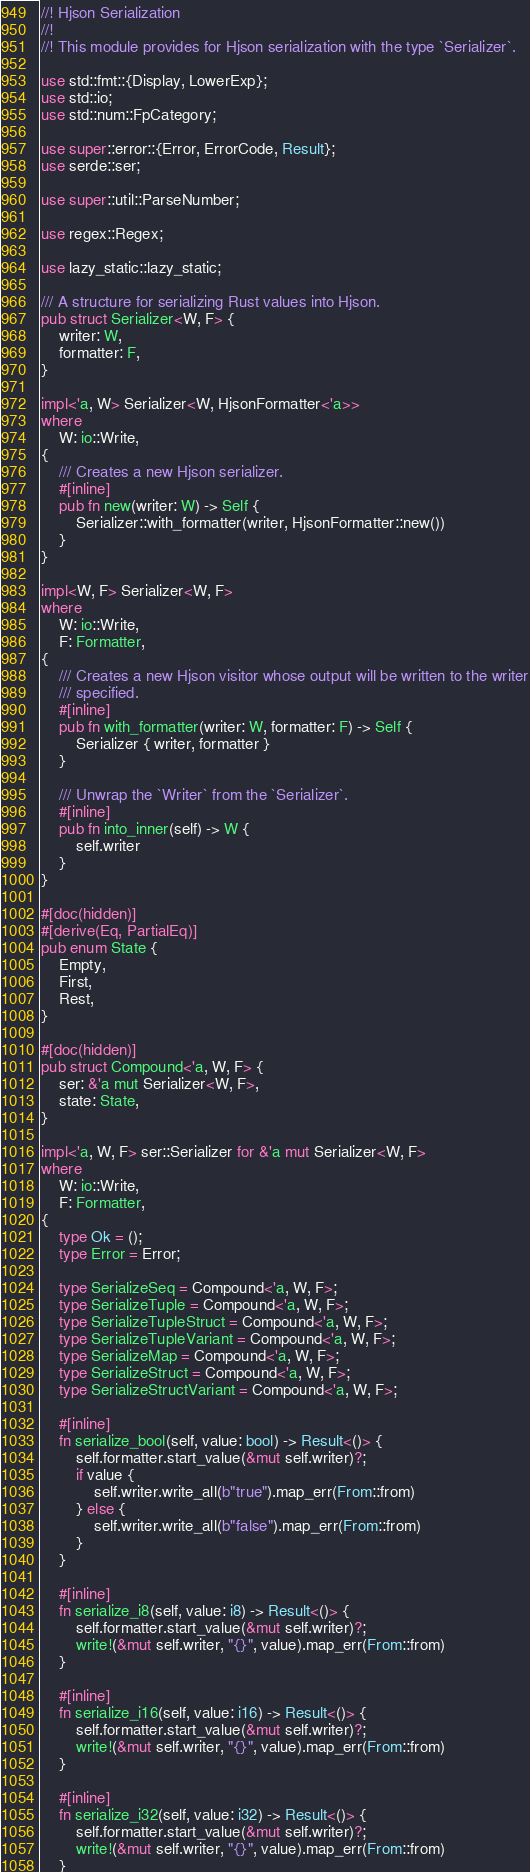<code> <loc_0><loc_0><loc_500><loc_500><_Rust_>//! Hjson Serialization
//!
//! This module provides for Hjson serialization with the type `Serializer`.

use std::fmt::{Display, LowerExp};
use std::io;
use std::num::FpCategory;

use super::error::{Error, ErrorCode, Result};
use serde::ser;

use super::util::ParseNumber;

use regex::Regex;

use lazy_static::lazy_static;

/// A structure for serializing Rust values into Hjson.
pub struct Serializer<W, F> {
    writer: W,
    formatter: F,
}

impl<'a, W> Serializer<W, HjsonFormatter<'a>>
where
    W: io::Write,
{
    /// Creates a new Hjson serializer.
    #[inline]
    pub fn new(writer: W) -> Self {
        Serializer::with_formatter(writer, HjsonFormatter::new())
    }
}

impl<W, F> Serializer<W, F>
where
    W: io::Write,
    F: Formatter,
{
    /// Creates a new Hjson visitor whose output will be written to the writer
    /// specified.
    #[inline]
    pub fn with_formatter(writer: W, formatter: F) -> Self {
        Serializer { writer, formatter }
    }

    /// Unwrap the `Writer` from the `Serializer`.
    #[inline]
    pub fn into_inner(self) -> W {
        self.writer
    }
}

#[doc(hidden)]
#[derive(Eq, PartialEq)]
pub enum State {
    Empty,
    First,
    Rest,
}

#[doc(hidden)]
pub struct Compound<'a, W, F> {
    ser: &'a mut Serializer<W, F>,
    state: State,
}

impl<'a, W, F> ser::Serializer for &'a mut Serializer<W, F>
where
    W: io::Write,
    F: Formatter,
{
    type Ok = ();
    type Error = Error;

    type SerializeSeq = Compound<'a, W, F>;
    type SerializeTuple = Compound<'a, W, F>;
    type SerializeTupleStruct = Compound<'a, W, F>;
    type SerializeTupleVariant = Compound<'a, W, F>;
    type SerializeMap = Compound<'a, W, F>;
    type SerializeStruct = Compound<'a, W, F>;
    type SerializeStructVariant = Compound<'a, W, F>;

    #[inline]
    fn serialize_bool(self, value: bool) -> Result<()> {
        self.formatter.start_value(&mut self.writer)?;
        if value {
            self.writer.write_all(b"true").map_err(From::from)
        } else {
            self.writer.write_all(b"false").map_err(From::from)
        }
    }

    #[inline]
    fn serialize_i8(self, value: i8) -> Result<()> {
        self.formatter.start_value(&mut self.writer)?;
        write!(&mut self.writer, "{}", value).map_err(From::from)
    }

    #[inline]
    fn serialize_i16(self, value: i16) -> Result<()> {
        self.formatter.start_value(&mut self.writer)?;
        write!(&mut self.writer, "{}", value).map_err(From::from)
    }

    #[inline]
    fn serialize_i32(self, value: i32) -> Result<()> {
        self.formatter.start_value(&mut self.writer)?;
        write!(&mut self.writer, "{}", value).map_err(From::from)
    }
</code> 